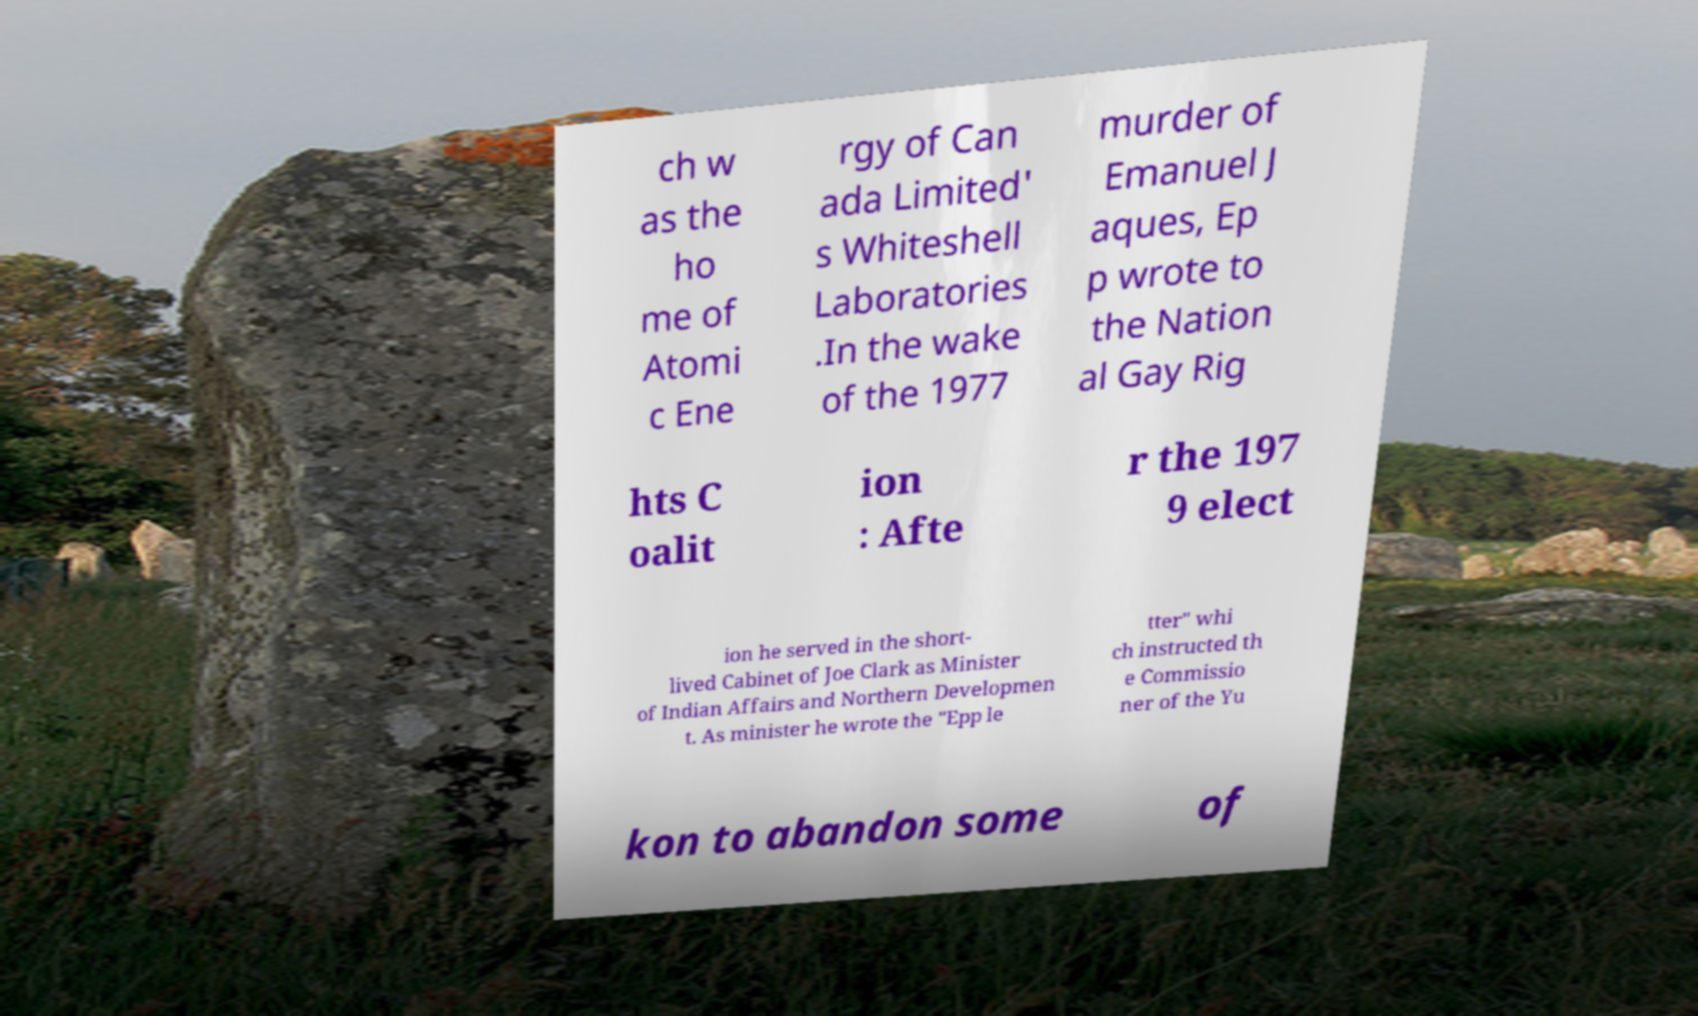Please read and relay the text visible in this image. What does it say? ch w as the ho me of Atomi c Ene rgy of Can ada Limited' s Whiteshell Laboratories .In the wake of the 1977 murder of Emanuel J aques, Ep p wrote to the Nation al Gay Rig hts C oalit ion : Afte r the 197 9 elect ion he served in the short- lived Cabinet of Joe Clark as Minister of Indian Affairs and Northern Developmen t. As minister he wrote the "Epp le tter" whi ch instructed th e Commissio ner of the Yu kon to abandon some of 